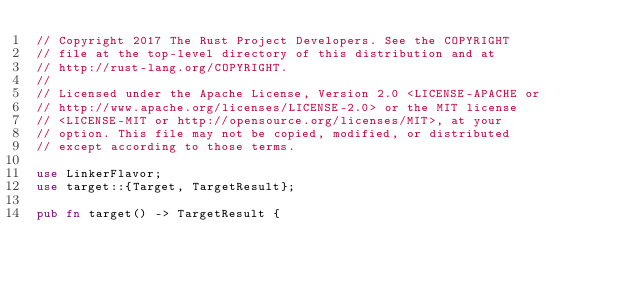<code> <loc_0><loc_0><loc_500><loc_500><_Rust_>// Copyright 2017 The Rust Project Developers. See the COPYRIGHT
// file at the top-level directory of this distribution and at
// http://rust-lang.org/COPYRIGHT.
//
// Licensed under the Apache License, Version 2.0 <LICENSE-APACHE or
// http://www.apache.org/licenses/LICENSE-2.0> or the MIT license
// <LICENSE-MIT or http://opensource.org/licenses/MIT>, at your
// option. This file may not be copied, modified, or distributed
// except according to those terms.

use LinkerFlavor;
use target::{Target, TargetResult};

pub fn target() -> TargetResult {</code> 